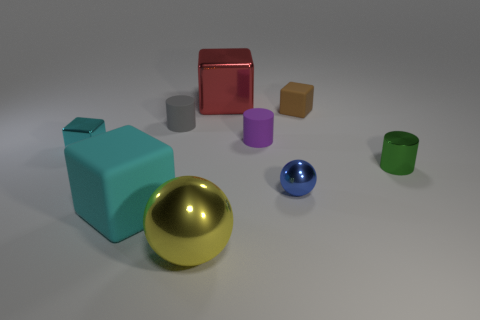There is a big matte thing that is the same color as the small metal block; what shape is it?
Provide a succinct answer. Cube. There is a cube that is the same color as the large rubber thing; what is its size?
Provide a short and direct response. Small. How many matte objects are the same size as the brown cube?
Offer a very short reply. 2. What is the color of the tiny metallic object that is both left of the small shiny cylinder and in front of the tiny cyan metallic thing?
Provide a succinct answer. Blue. Are there fewer large metallic objects than small brown cubes?
Provide a short and direct response. No. There is a big matte thing; does it have the same color as the tiny block that is left of the brown thing?
Your answer should be very brief. Yes. Are there an equal number of shiny cylinders that are to the left of the tiny metal cube and yellow metallic balls behind the large cyan matte block?
Offer a terse response. Yes. How many large green rubber objects are the same shape as the tiny purple object?
Your response must be concise. 0. Are there any small brown rubber balls?
Provide a succinct answer. No. Is the material of the large sphere the same as the cyan cube that is right of the cyan metal cube?
Offer a terse response. No. 